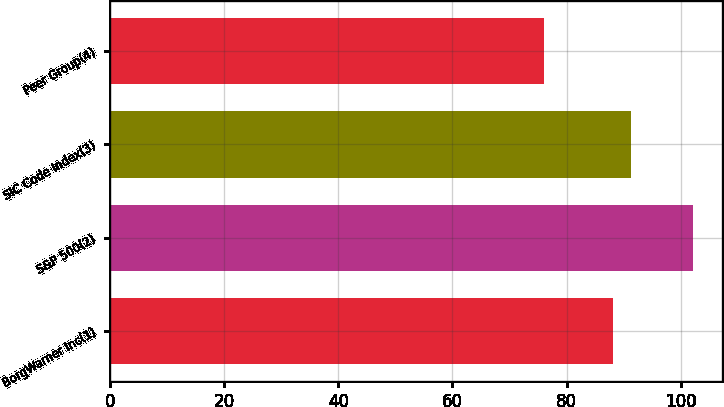<chart> <loc_0><loc_0><loc_500><loc_500><bar_chart><fcel>BorgWarner Inc(1)<fcel>S&P 500(2)<fcel>SIC Code Index(3)<fcel>Peer Group(4)<nl><fcel>88.09<fcel>102.11<fcel>91.24<fcel>76.02<nl></chart> 